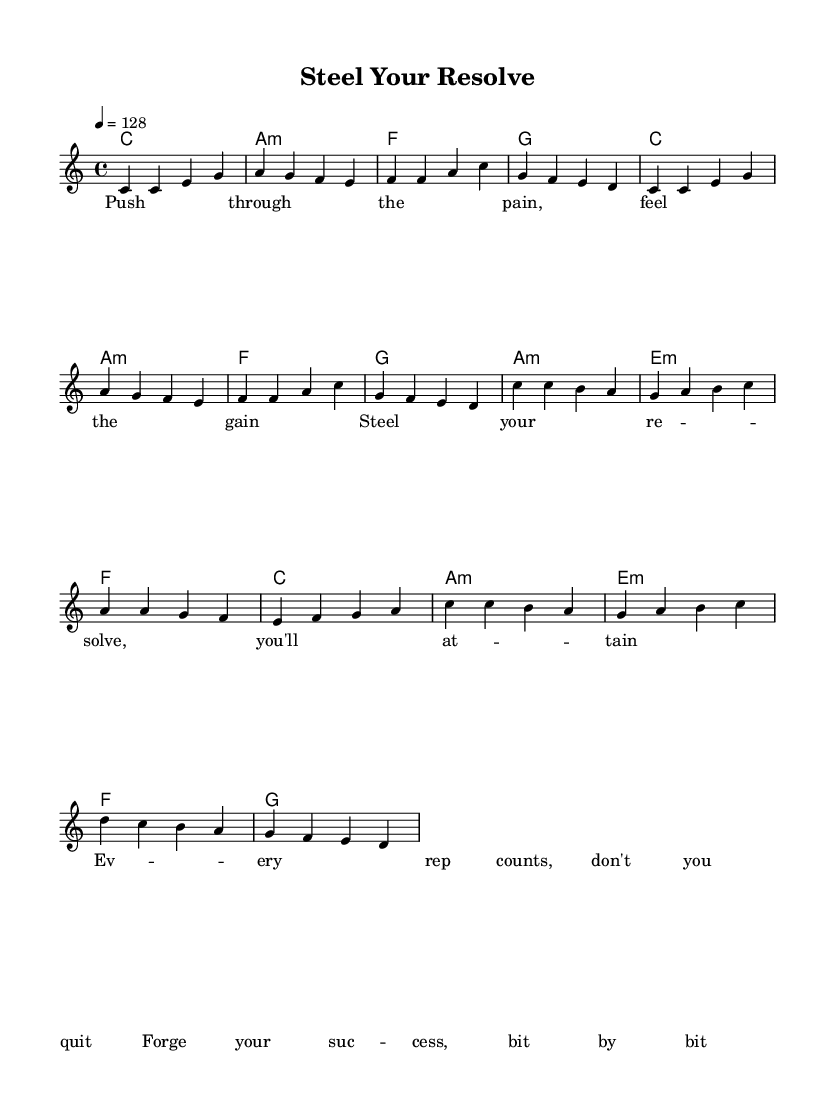What is the key signature of this music? The key signature is indicated at the beginning of the score, showing no sharps or flats. Therefore, it is C major.
Answer: C major What is the time signature of this music? The time signature appears near the beginning of the score. It is written as "4/4", meaning there are four beats in each measure.
Answer: 4/4 What is the tempo marking for this music? The tempo is marked at the beginning with "4 = 128", indicating the speed of the piece in beats per minute.
Answer: 128 How many measures are in the melody section? Counting the distinct measures in the melody line reveals that there are 16 measures total in the provided melody.
Answer: 16 What is the first lyric line of the verse? The lyrics for the verse are located underneath the melody. The first line reads "Push through the pain, feel the gain".
Answer: Push through the pain, feel the gain Which chord is used in measure 4? By looking at the chord changes positioned above the melody, the chord in measure 4 is identified as G.
Answer: G What motivational theme is prominent in the lyrics? Analyzing the lyrics, the main theme revolves around perseverance and achieving success through effort, emphasizing a motivational tone.
Answer: Perseverance 